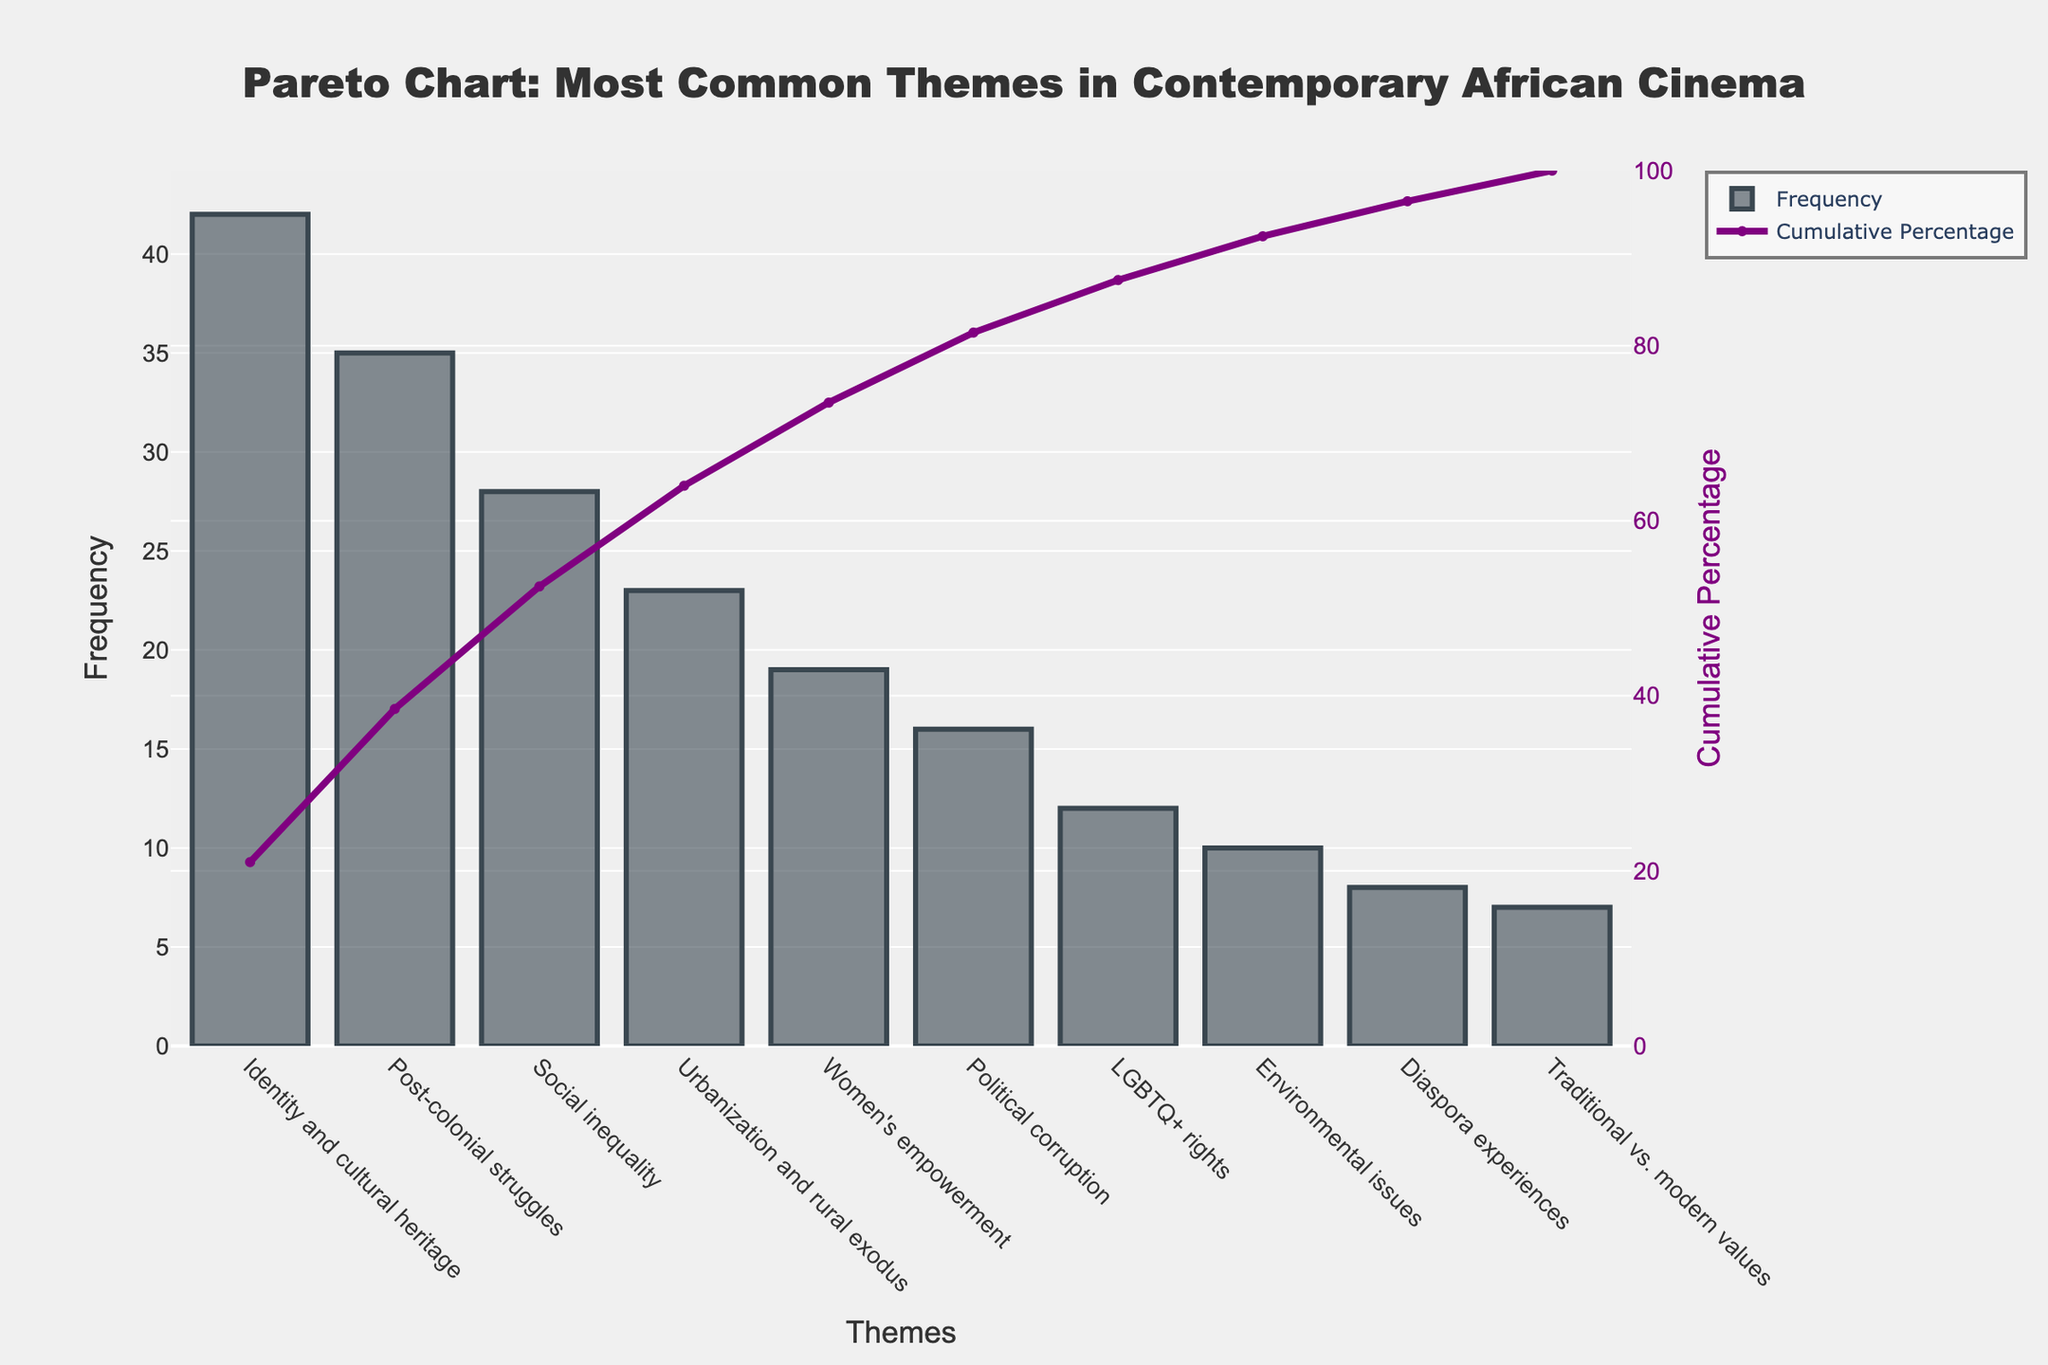What is the most common theme in contemporary African cinema? The most common theme can be identified as the highest bar in the bar chart. The theme with the highest frequency is "Identity and cultural heritage."
Answer: Identity and cultural heritage What is the cumulative percentage for "Social inequality"? Locate the point on the scatter plot corresponding to "Social inequality" on the x-axis and find its associated y-value. The cumulative percentage shown for "Social inequality" is around 78.5%.
Answer: 78.5% Which theme has the lowest frequency? The theme with the shortest bar in the bar chart represents the lowest frequency. The theme with the lowest frequency is "Traditional vs. modern values."
Answer: Traditional vs. modern values How many themes have a cumulative percentage over 90%? Look for points on the scatter plot where the cumulative percentage exceeds 90%. Count these points from left to right starting from the x-axis. Only the themes "Traditional vs. modern values" and "Diaspora experiences" fall within this range.
Answer: 2 How does the frequency of "Political corruption" compare to "Women's empowerment"? Refer to the heights of the bars representing these themes. The bar for "Political corruption" is shorter than the one for "Women's empowerment." The frequency for "Political corruption" is 16, while for "Women's empowerment," it is 19.
Answer: Women's empowerment has a higher frequency than Political corruption What cumulative percentage do the top three themes account for? Add the cumulative percentages corresponding to the top three themes: "Identity and cultural heritage," "Post-colonial struggles," and "Social inequality." Their cumulative percentages are approximately 28.9%, 53.2%, and 78.5%, respectively.
Answer: 78.5% Does "Environmental issues" contribute more or less than 10% to the cumulative percentage? Look at the cumulative percentage value for "Environmental issues." The bar corresponds to approximately 95% on the cumulative percentage axis, indicating all themes before it account for 85%. This means "Environmental issues" contributes approximately 10%.
Answer: More Which theme has the highest difference in frequency compared to the next less common theme? To find the highest difference, calculate the differences between consecutive frequencies: of "Identity and cultural heritage" over "Post-colonial struggles" is (42-35 = 7), "Post-colonial struggles" over "Social inequality" is (35-28 = 7), and so forth. The largest difference is between "Identity and cultural heritage" (42) and "Post-colonial struggles" (35).
Answer: Identity and cultural heritage and Post-colonial struggles What percentage of the total is contributed by the themes with the lowest and the highest frequency combined? The lowest frequency is 7 ("Traditional vs. modern values") and the highest is 42 ("Identity and cultural heritage"). The total frequency is the sum of all the values which is 200. Therefore, (7+42)/200*100% is approximately 24.5%.
Answer: 24.5% What is the cumulative frequency of the first five themes combined? Add the frequencies of the first five themes: 42 (Identity and cultural heritage) + 35 (Post-colonial struggles) + 28 (Social inequality) + 23 (Urbanization and rural exodus) + 19 (Women's empowerment) = 147.
Answer: 147 